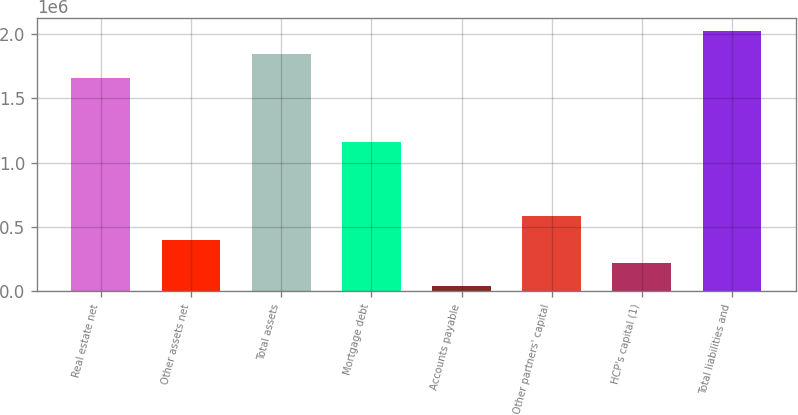Convert chart to OTSL. <chart><loc_0><loc_0><loc_500><loc_500><bar_chart><fcel>Real estate net<fcel>Other assets net<fcel>Total assets<fcel>Mortgage debt<fcel>Accounts payable<fcel>Other partners' capital<fcel>HCP's capital (1)<fcel>Total liabilities and<nl><fcel>1.65575e+06<fcel>399723<fcel>1.8456e+06<fcel>1.15959e+06<fcel>38255<fcel>580457<fcel>218989<fcel>2.02633e+06<nl></chart> 